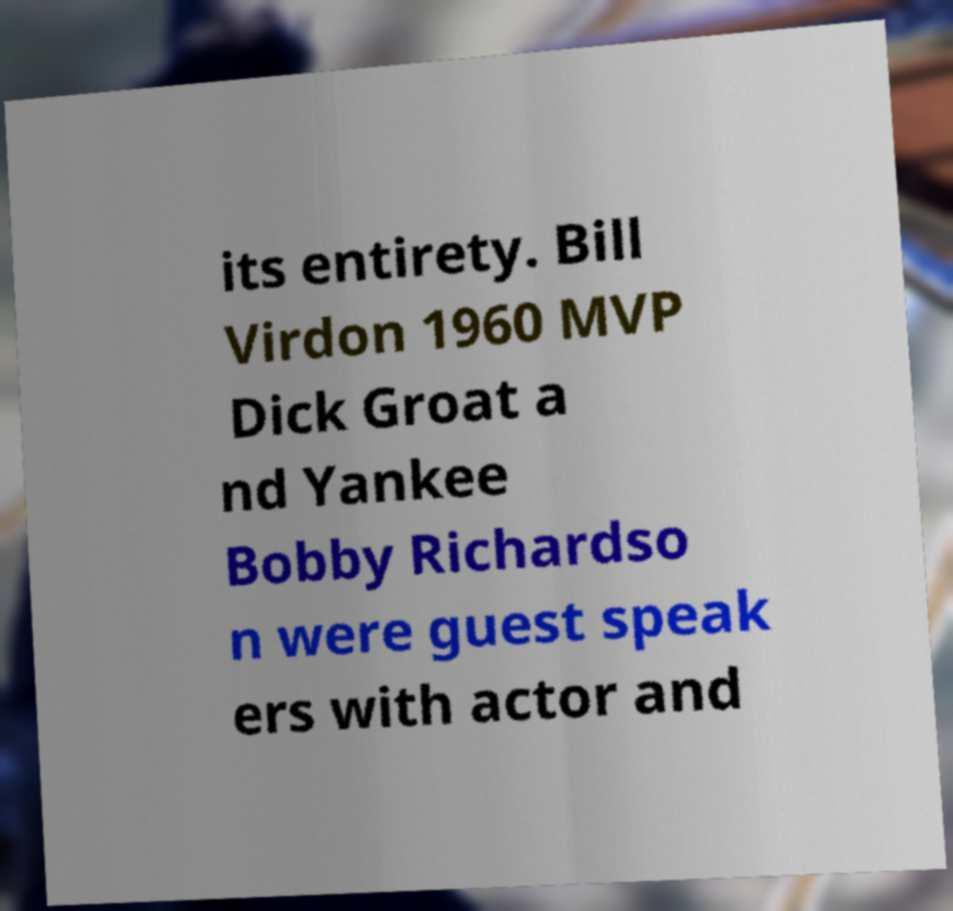Could you assist in decoding the text presented in this image and type it out clearly? its entirety. Bill Virdon 1960 MVP Dick Groat a nd Yankee Bobby Richardso n were guest speak ers with actor and 